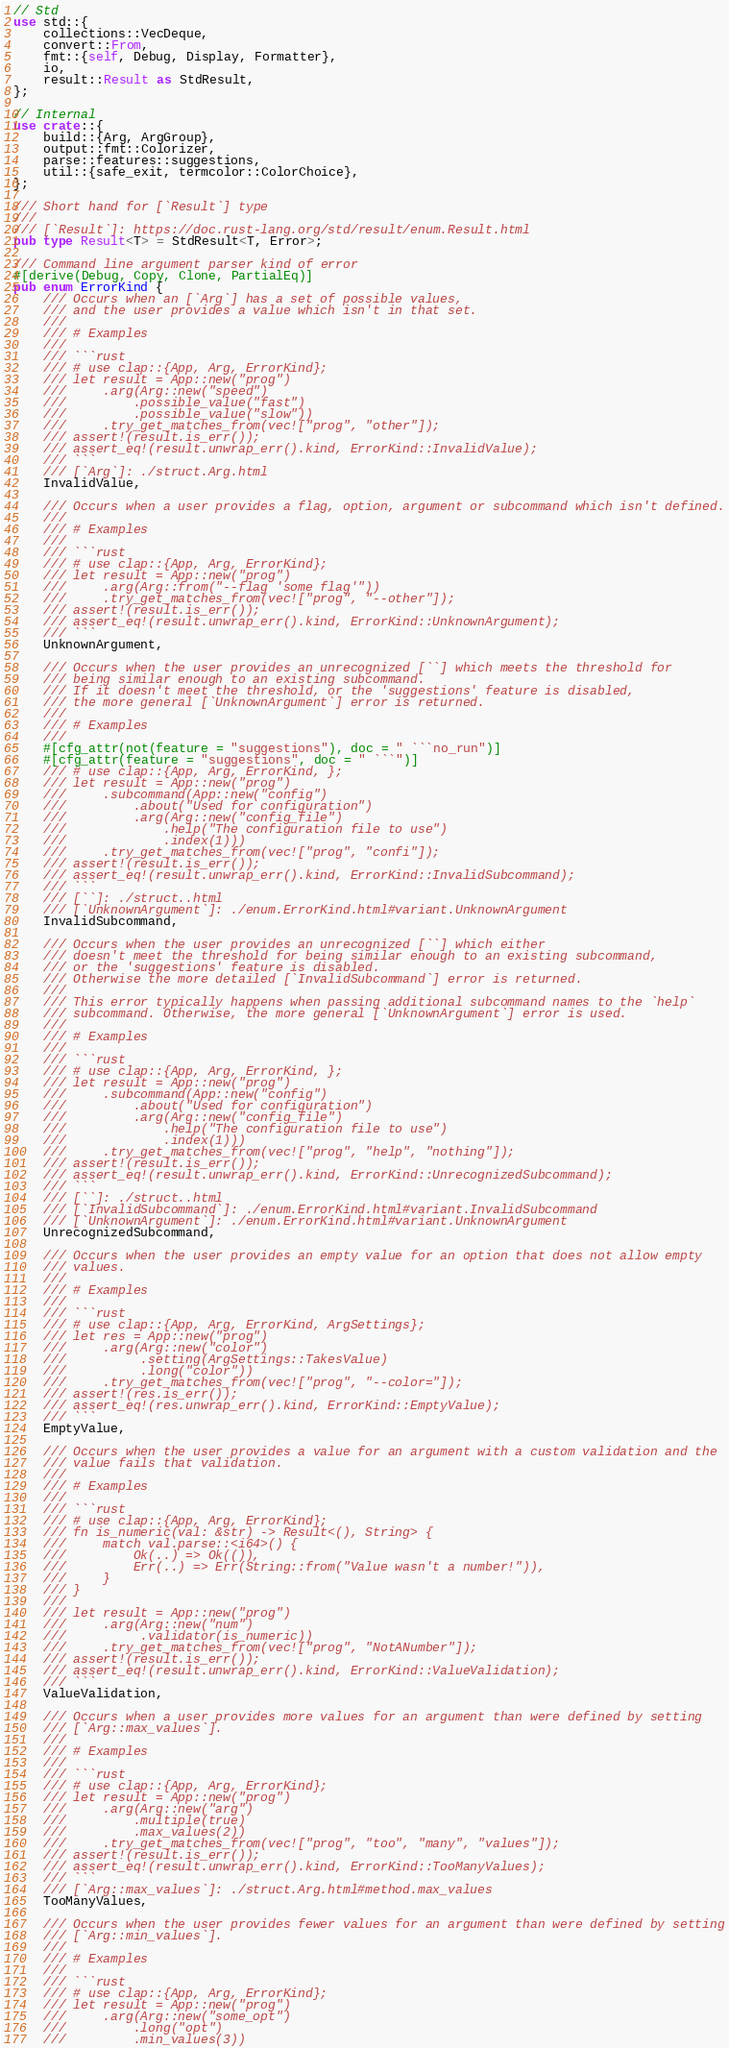<code> <loc_0><loc_0><loc_500><loc_500><_Rust_>// Std
use std::{
    collections::VecDeque,
    convert::From,
    fmt::{self, Debug, Display, Formatter},
    io,
    result::Result as StdResult,
};

// Internal
use crate::{
    build::{Arg, ArgGroup},
    output::fmt::Colorizer,
    parse::features::suggestions,
    util::{safe_exit, termcolor::ColorChoice},
};

/// Short hand for [`Result`] type
///
/// [`Result`]: https://doc.rust-lang.org/std/result/enum.Result.html
pub type Result<T> = StdResult<T, Error>;

/// Command line argument parser kind of error
#[derive(Debug, Copy, Clone, PartialEq)]
pub enum ErrorKind {
    /// Occurs when an [`Arg`] has a set of possible values,
    /// and the user provides a value which isn't in that set.
    ///
    /// # Examples
    ///
    /// ```rust
    /// # use clap::{App, Arg, ErrorKind};
    /// let result = App::new("prog")
    ///     .arg(Arg::new("speed")
    ///         .possible_value("fast")
    ///         .possible_value("slow"))
    ///     .try_get_matches_from(vec!["prog", "other"]);
    /// assert!(result.is_err());
    /// assert_eq!(result.unwrap_err().kind, ErrorKind::InvalidValue);
    /// ```
    /// [`Arg`]: ./struct.Arg.html
    InvalidValue,

    /// Occurs when a user provides a flag, option, argument or subcommand which isn't defined.
    ///
    /// # Examples
    ///
    /// ```rust
    /// # use clap::{App, Arg, ErrorKind};
    /// let result = App::new("prog")
    ///     .arg(Arg::from("--flag 'some flag'"))
    ///     .try_get_matches_from(vec!["prog", "--other"]);
    /// assert!(result.is_err());
    /// assert_eq!(result.unwrap_err().kind, ErrorKind::UnknownArgument);
    /// ```
    UnknownArgument,

    /// Occurs when the user provides an unrecognized [``] which meets the threshold for
    /// being similar enough to an existing subcommand.
    /// If it doesn't meet the threshold, or the 'suggestions' feature is disabled,
    /// the more general [`UnknownArgument`] error is returned.
    ///
    /// # Examples
    ///
    #[cfg_attr(not(feature = "suggestions"), doc = " ```no_run")]
    #[cfg_attr(feature = "suggestions", doc = " ```")]
    /// # use clap::{App, Arg, ErrorKind, };
    /// let result = App::new("prog")
    ///     .subcommand(App::new("config")
    ///         .about("Used for configuration")
    ///         .arg(Arg::new("config_file")
    ///             .help("The configuration file to use")
    ///             .index(1)))
    ///     .try_get_matches_from(vec!["prog", "confi"]);
    /// assert!(result.is_err());
    /// assert_eq!(result.unwrap_err().kind, ErrorKind::InvalidSubcommand);
    /// ```
    /// [``]: ./struct..html
    /// [`UnknownArgument`]: ./enum.ErrorKind.html#variant.UnknownArgument
    InvalidSubcommand,

    /// Occurs when the user provides an unrecognized [``] which either
    /// doesn't meet the threshold for being similar enough to an existing subcommand,
    /// or the 'suggestions' feature is disabled.
    /// Otherwise the more detailed [`InvalidSubcommand`] error is returned.
    ///
    /// This error typically happens when passing additional subcommand names to the `help`
    /// subcommand. Otherwise, the more general [`UnknownArgument`] error is used.
    ///
    /// # Examples
    ///
    /// ```rust
    /// # use clap::{App, Arg, ErrorKind, };
    /// let result = App::new("prog")
    ///     .subcommand(App::new("config")
    ///         .about("Used for configuration")
    ///         .arg(Arg::new("config_file")
    ///             .help("The configuration file to use")
    ///             .index(1)))
    ///     .try_get_matches_from(vec!["prog", "help", "nothing"]);
    /// assert!(result.is_err());
    /// assert_eq!(result.unwrap_err().kind, ErrorKind::UnrecognizedSubcommand);
    /// ```
    /// [``]: ./struct..html
    /// [`InvalidSubcommand`]: ./enum.ErrorKind.html#variant.InvalidSubcommand
    /// [`UnknownArgument`]: ./enum.ErrorKind.html#variant.UnknownArgument
    UnrecognizedSubcommand,

    /// Occurs when the user provides an empty value for an option that does not allow empty
    /// values.
    ///
    /// # Examples
    ///
    /// ```rust
    /// # use clap::{App, Arg, ErrorKind, ArgSettings};
    /// let res = App::new("prog")
    ///     .arg(Arg::new("color")
    ///          .setting(ArgSettings::TakesValue)
    ///          .long("color"))
    ///     .try_get_matches_from(vec!["prog", "--color="]);
    /// assert!(res.is_err());
    /// assert_eq!(res.unwrap_err().kind, ErrorKind::EmptyValue);
    /// ```
    EmptyValue,

    /// Occurs when the user provides a value for an argument with a custom validation and the
    /// value fails that validation.
    ///
    /// # Examples
    ///
    /// ```rust
    /// # use clap::{App, Arg, ErrorKind};
    /// fn is_numeric(val: &str) -> Result<(), String> {
    ///     match val.parse::<i64>() {
    ///         Ok(..) => Ok(()),
    ///         Err(..) => Err(String::from("Value wasn't a number!")),
    ///     }
    /// }
    ///
    /// let result = App::new("prog")
    ///     .arg(Arg::new("num")
    ///          .validator(is_numeric))
    ///     .try_get_matches_from(vec!["prog", "NotANumber"]);
    /// assert!(result.is_err());
    /// assert_eq!(result.unwrap_err().kind, ErrorKind::ValueValidation);
    /// ```
    ValueValidation,

    /// Occurs when a user provides more values for an argument than were defined by setting
    /// [`Arg::max_values`].
    ///
    /// # Examples
    ///
    /// ```rust
    /// # use clap::{App, Arg, ErrorKind};
    /// let result = App::new("prog")
    ///     .arg(Arg::new("arg")
    ///         .multiple(true)
    ///         .max_values(2))
    ///     .try_get_matches_from(vec!["prog", "too", "many", "values"]);
    /// assert!(result.is_err());
    /// assert_eq!(result.unwrap_err().kind, ErrorKind::TooManyValues);
    /// ```
    /// [`Arg::max_values`]: ./struct.Arg.html#method.max_values
    TooManyValues,

    /// Occurs when the user provides fewer values for an argument than were defined by setting
    /// [`Arg::min_values`].
    ///
    /// # Examples
    ///
    /// ```rust
    /// # use clap::{App, Arg, ErrorKind};
    /// let result = App::new("prog")
    ///     .arg(Arg::new("some_opt")
    ///         .long("opt")
    ///         .min_values(3))</code> 